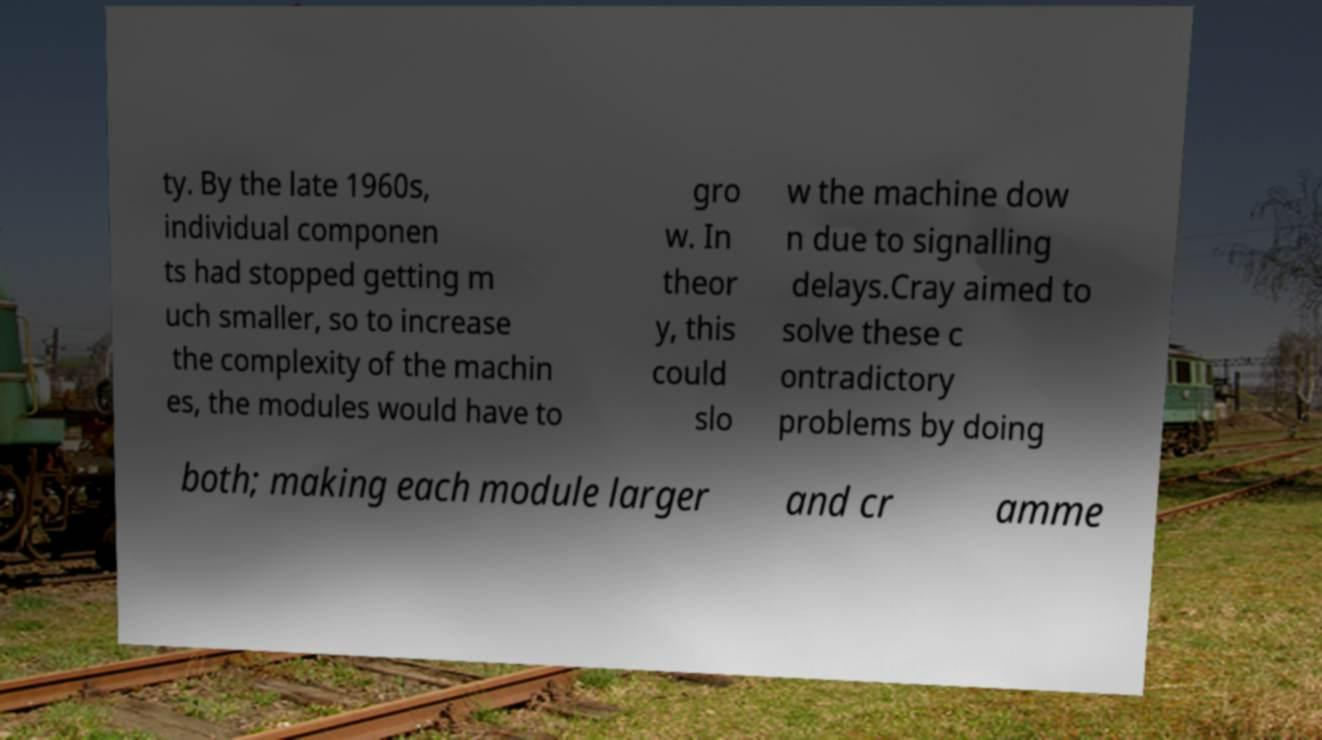Could you assist in decoding the text presented in this image and type it out clearly? ty. By the late 1960s, individual componen ts had stopped getting m uch smaller, so to increase the complexity of the machin es, the modules would have to gro w. In theor y, this could slo w the machine dow n due to signalling delays.Cray aimed to solve these c ontradictory problems by doing both; making each module larger and cr amme 